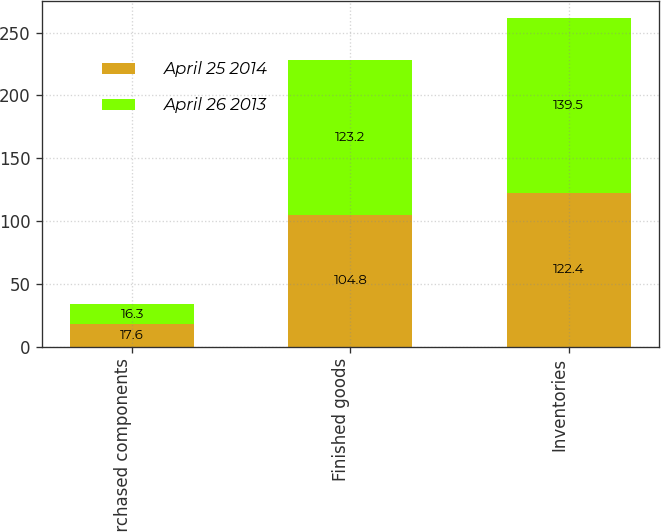Convert chart to OTSL. <chart><loc_0><loc_0><loc_500><loc_500><stacked_bar_chart><ecel><fcel>Purchased components<fcel>Finished goods<fcel>Inventories<nl><fcel>April 25 2014<fcel>17.6<fcel>104.8<fcel>122.4<nl><fcel>April 26 2013<fcel>16.3<fcel>123.2<fcel>139.5<nl></chart> 